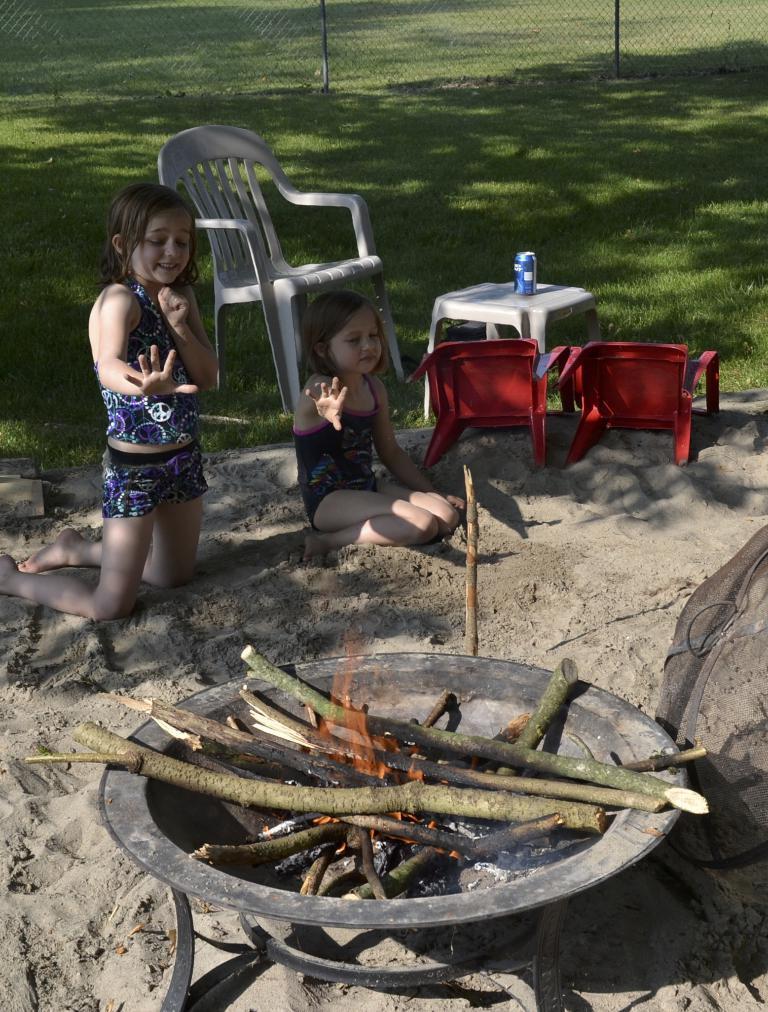Can you describe this image briefly? In this image we can see campfire, children sitting on the sand, chairs, beverage bottle, mesh and ground. 